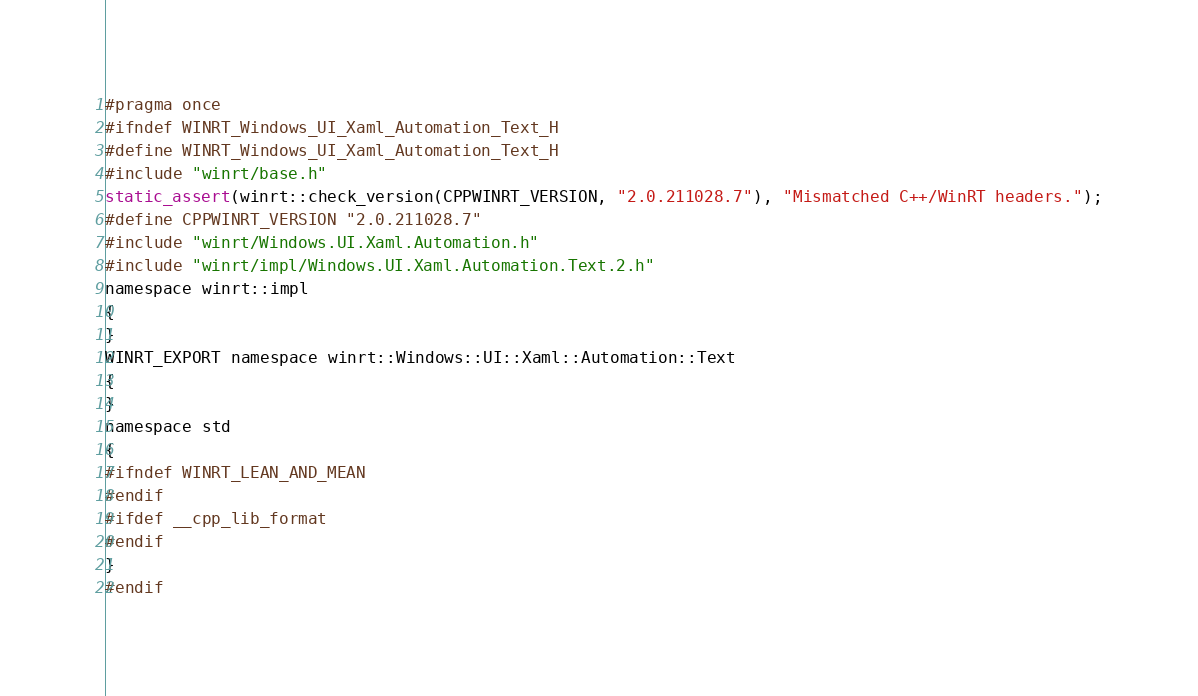Convert code to text. <code><loc_0><loc_0><loc_500><loc_500><_C_>
#pragma once
#ifndef WINRT_Windows_UI_Xaml_Automation_Text_H
#define WINRT_Windows_UI_Xaml_Automation_Text_H
#include "winrt/base.h"
static_assert(winrt::check_version(CPPWINRT_VERSION, "2.0.211028.7"), "Mismatched C++/WinRT headers.");
#define CPPWINRT_VERSION "2.0.211028.7"
#include "winrt/Windows.UI.Xaml.Automation.h"
#include "winrt/impl/Windows.UI.Xaml.Automation.Text.2.h"
namespace winrt::impl
{
}
WINRT_EXPORT namespace winrt::Windows::UI::Xaml::Automation::Text
{
}
namespace std
{
#ifndef WINRT_LEAN_AND_MEAN
#endif
#ifdef __cpp_lib_format
#endif
}
#endif
</code> 